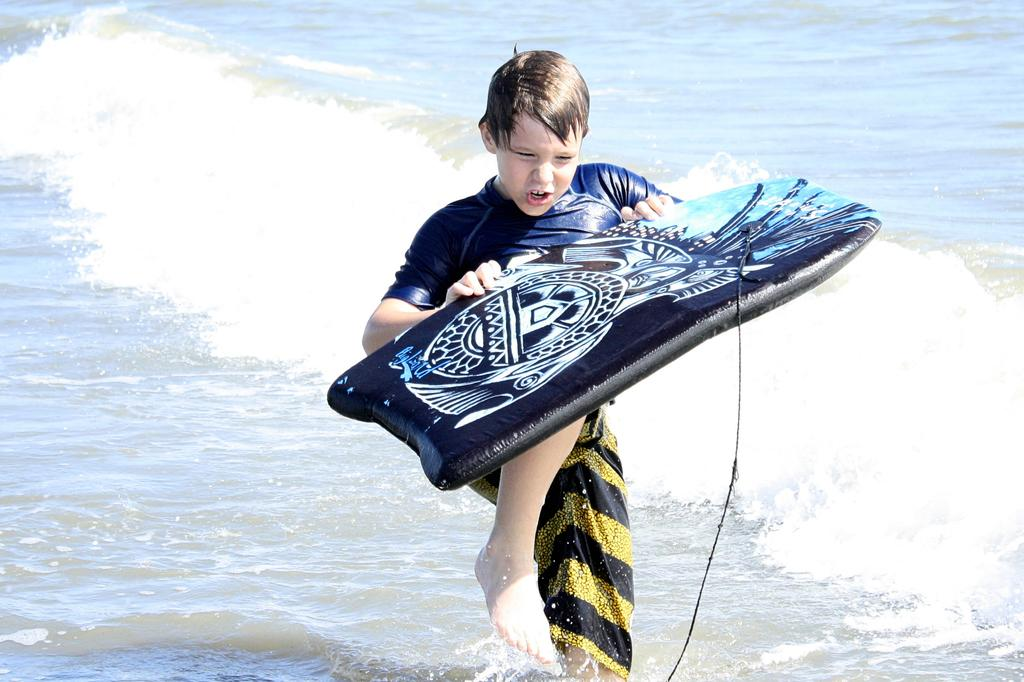What type of water body is shown in the image? The image depicts a freshwater river. Can you describe any specific features of the river? There is a wave visible in the river. What is the boy in the image doing? The boy is standing in the image. What object is the boy holding? The boy is holding a surfboard. What type of pest can be seen crawling on the boy's surfboard in the image? There is no pest visible on the boy's surfboard in the image. What is the weight of the surfboard the boy is holding? The weight of the surfboard cannot be determined from the image alone. 